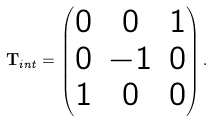<formula> <loc_0><loc_0><loc_500><loc_500>\mathbf T _ { i n t } = \begin{pmatrix} 0 & 0 & 1 \\ 0 & - 1 & 0 \\ 1 & 0 & 0 \end{pmatrix} .</formula> 